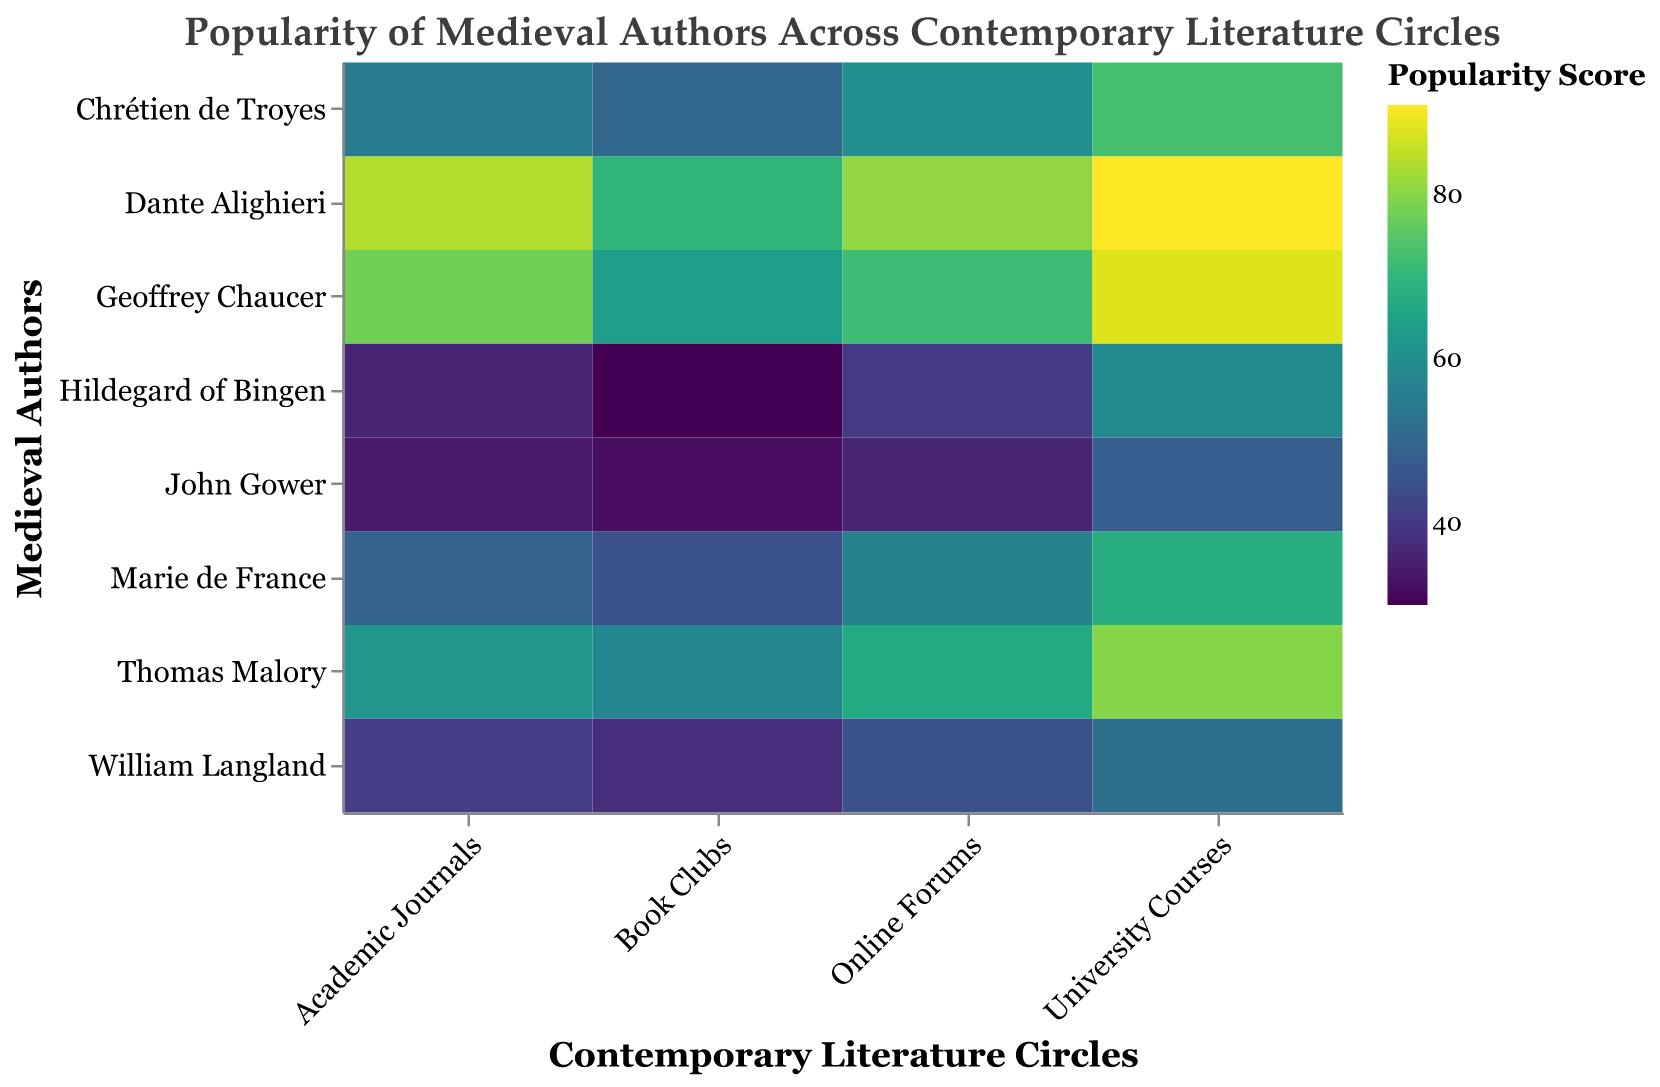What is the popularity score of Dante Alighieri in University Courses? Locate the cell where the "Author" axis matches Dante Alighieri and the "Contemporary Literature Circles" axis matches University Courses. The color intensity and tooltip indicate the popularity score is 91.
Answer: 91 Which author has the highest popularity score in Online Forums? Compare the Online Forums column for all authors. Dante Alighieri has the highest popularity score in Online Forums with a score of 81.
Answer: Dante Alighieri How does the popularity of Geoffrey Chaucer in Academic Journals compare to Hildegard of Bingen's popularity in the same circle? Look at the Academic Journals row for Geoffrey Chaucer and Hildegard of Bingen. Chaucer's score is 78, and Hildegard's is 36. Thus, Chaucer is more popular in Academic Journals.
Answer: Geoffrey Chaucer is more popular What are the two least popular categories for Marie de France? Identify Marie de France on the "Author" axis and compare her popularity scores across all "Contemporary Literature Circles". The two least popular categories are Book Clubs (45) and Academic Journals (49).
Answer: Book Clubs and Academic Journals Which contemporary literature circle most equally represents Chrétien de Troyes and Thomas Malory? Compare the popularity scores of Chrétien de Troyes and Thomas Malory across all categories. The differences are: Academic Journals (7), Book Clubs (8), Online Forums (7), University Courses (7). The most equal difference is in Online Forums, with a difference of 7.
Answer: Online Forums What is the average popularity score of Geoffrey Chaucer across all literature circles? Sum the popularity scores of Geoffrey Chaucer in each contemporary literature circle (78 + 64 + 72 + 88) = 302 and divide by 4. The average is 302/4 = 75.5
Answer: 75.5 Which author shows the most consistent popularity across different literature circles? Determine the variance or range of popularity scores for each author. Dante Alighieri’s scores are 84, 70, 81, and 91, showing the smallest range of 21 (91-70), compared to others.
Answer: Dante Alighieri How does the popularity of William Langland in University Courses compare to his popularity in Online Forums? Locate William Langland on the "Author" axis and compare his popularity in University Courses (52) to Online Forums (45). There is a difference of 7 points, with University Courses being higher.
Answer: University Courses is higher What is the least popular category overall for the listed authors? Sum the popularity scores for each category across all authors: Academic Journals (?), Book Clubs (?), Online Forums (?), University Courses (?). The category with the smallest total sum is the least popular. Academic Journals = 439, Book Clubs = 387, Online Forums = 458, University Courses = 559. The least popular category overall is Book Clubs.
Answer: Book Clubs 